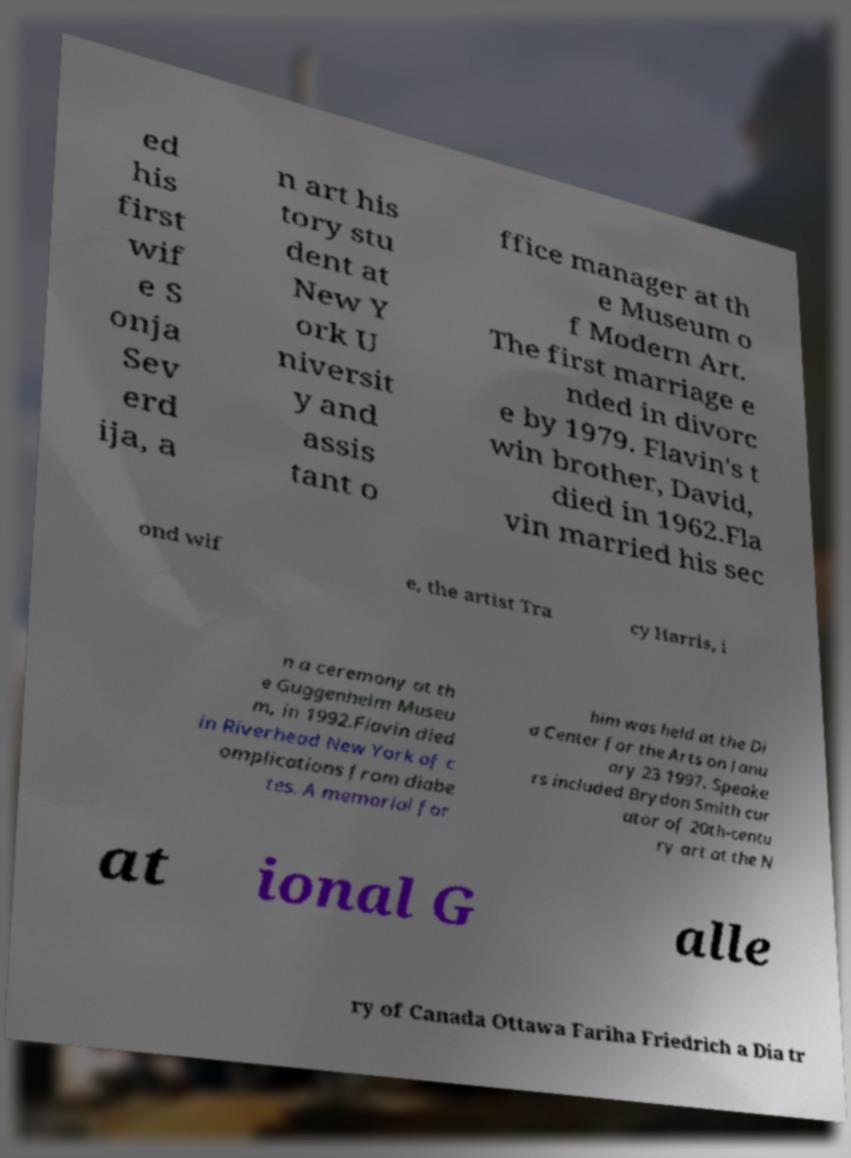Please identify and transcribe the text found in this image. ed his first wif e S onja Sev erd ija, a n art his tory stu dent at New Y ork U niversit y and assis tant o ffice manager at th e Museum o f Modern Art. The first marriage e nded in divorc e by 1979. Flavin's t win brother, David, died in 1962.Fla vin married his sec ond wif e, the artist Tra cy Harris, i n a ceremony at th e Guggenheim Museu m, in 1992.Flavin died in Riverhead New York of c omplications from diabe tes. A memorial for him was held at the Di a Center for the Arts on Janu ary 23 1997. Speake rs included Brydon Smith cur ator of 20th-centu ry art at the N at ional G alle ry of Canada Ottawa Fariha Friedrich a Dia tr 